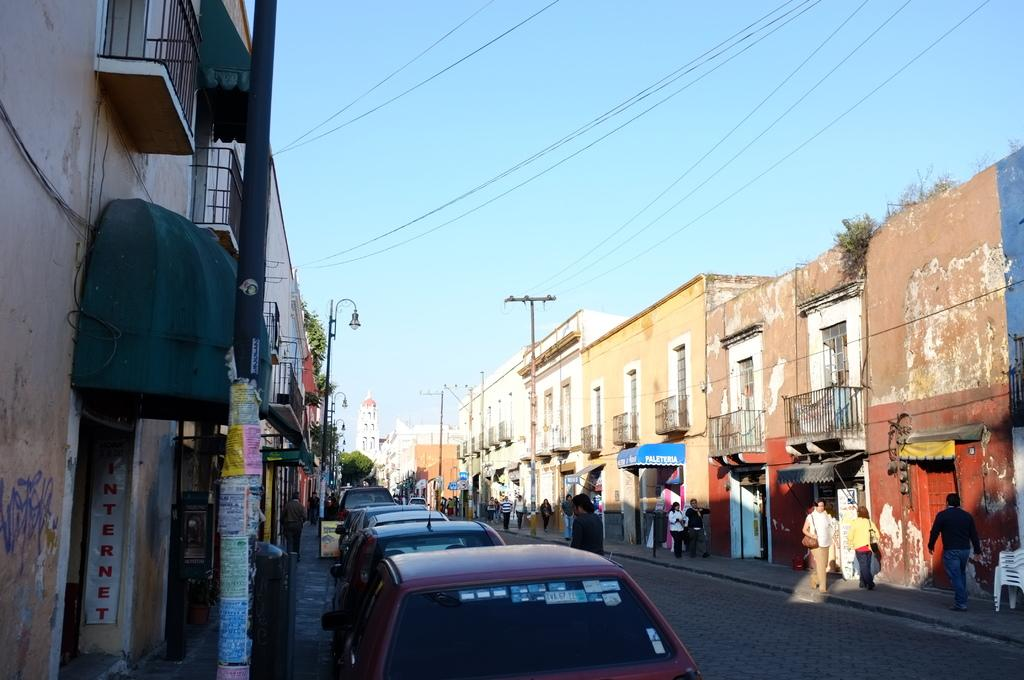What can be seen on the road in the image? There are vehicles on the road in the image. What else is present near the vehicles? There are people beside the vehicles. What can be seen in the distance in the image? There are buildings, trees, and the sky visible in the background of the image. What type of creature is climbing the wall in the image? There is no creature climbing a wall in the image. What paste is being used to stick the vehicles to the road in the image? There is no paste being used to stick the vehicles to the road in the image; they are simply driving on the road. 